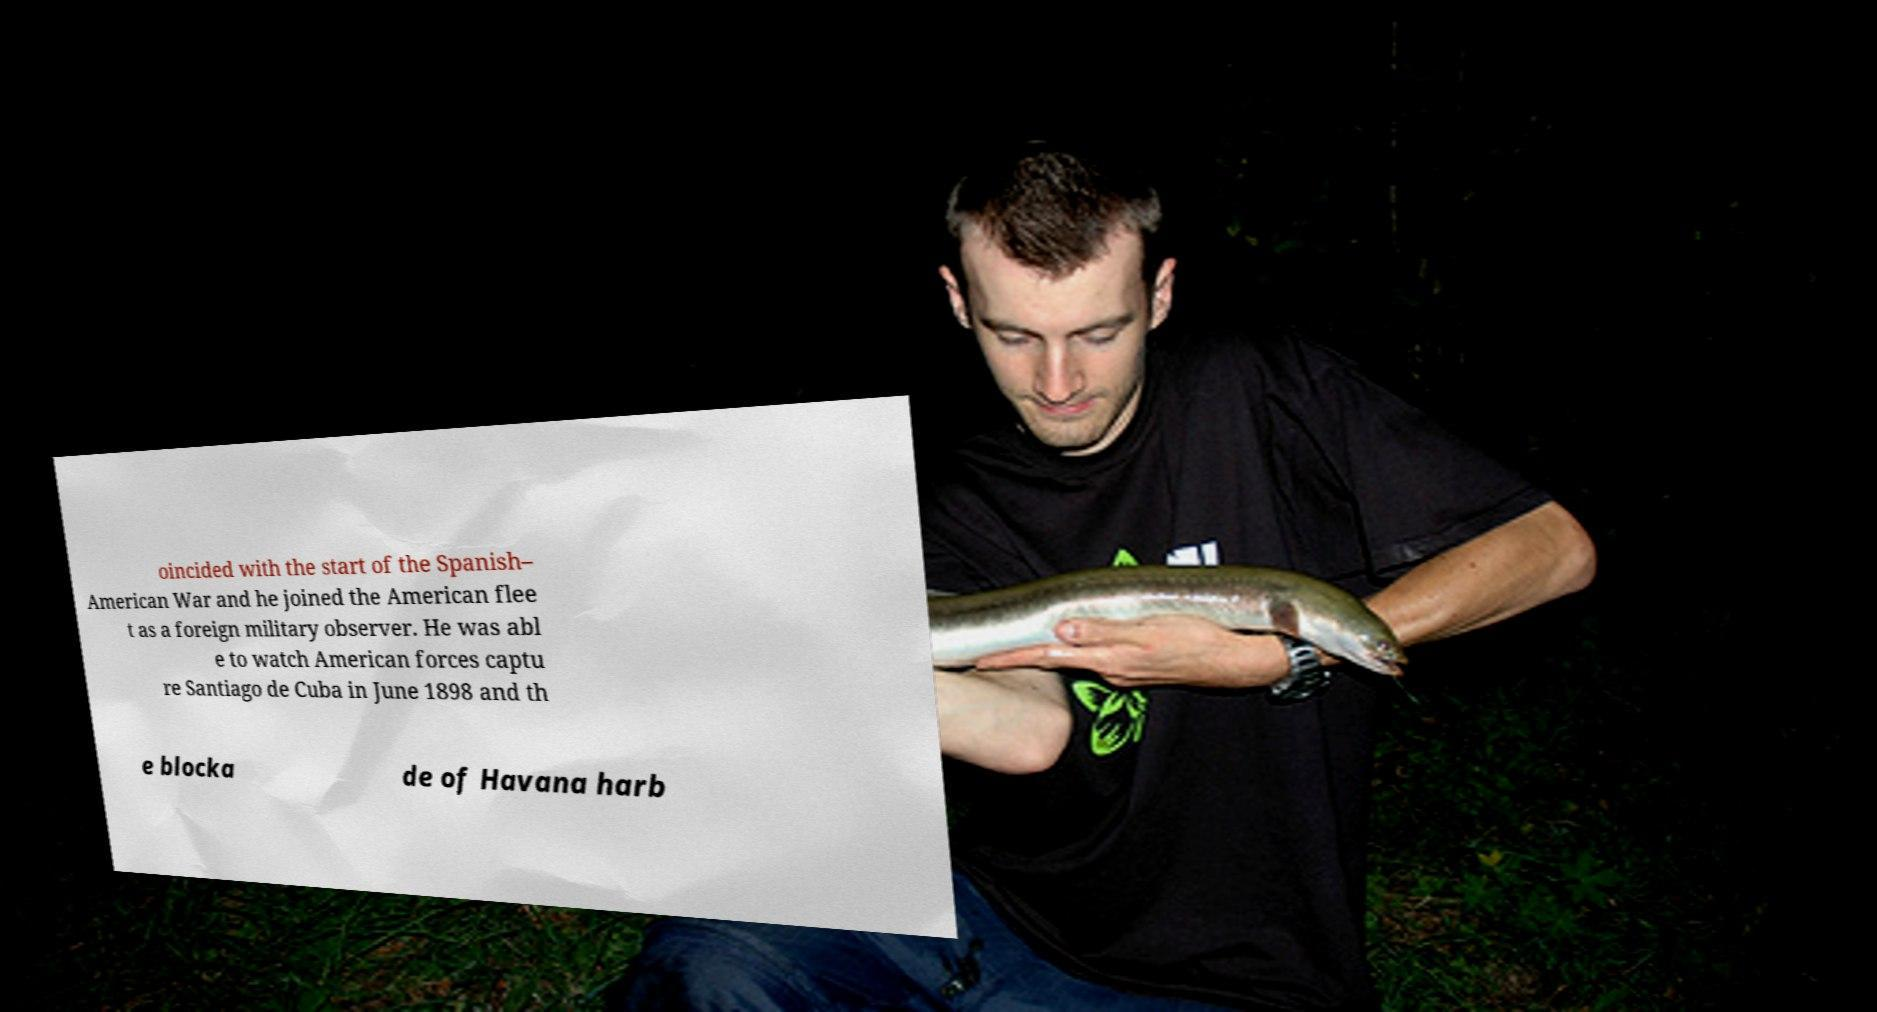What messages or text are displayed in this image? I need them in a readable, typed format. oincided with the start of the Spanish– American War and he joined the American flee t as a foreign military observer. He was abl e to watch American forces captu re Santiago de Cuba in June 1898 and th e blocka de of Havana harb 